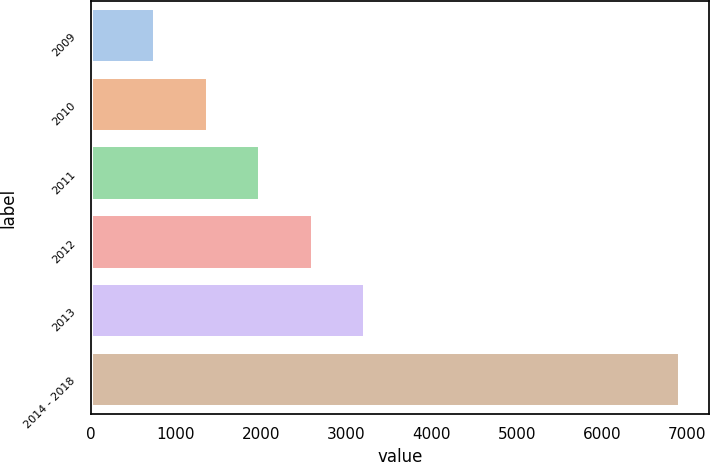Convert chart. <chart><loc_0><loc_0><loc_500><loc_500><bar_chart><fcel>2009<fcel>2010<fcel>2011<fcel>2012<fcel>2013<fcel>2014 - 2018<nl><fcel>760<fcel>1375.1<fcel>1990.2<fcel>2605.3<fcel>3220.4<fcel>6911<nl></chart> 